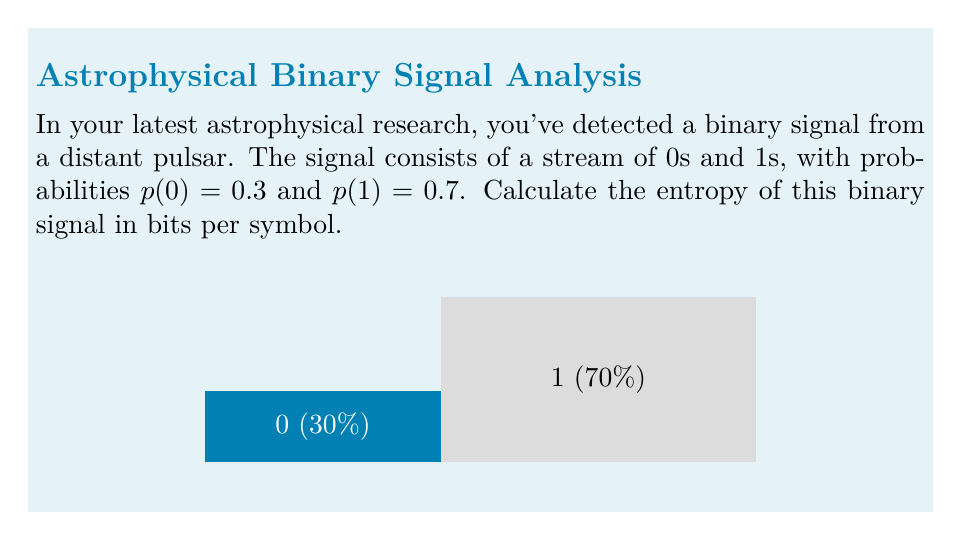Could you help me with this problem? To calculate the entropy of a binary signal, we use Shannon's entropy formula:

$$H = -\sum_{i} p(i) \log_2 p(i)$$

Where $p(i)$ is the probability of each symbol in the signal.

For our binary signal:
1) $p(0) = 0.3$ and $p(1) = 0.7$

2) Let's calculate each term:
   For 0: $-0.3 \log_2(0.3)$
   For 1: $-0.7 \log_2(0.7)$

3) Using a calculator or logarithm properties:
   $-0.3 \log_2(0.3) \approx 0.3219$ bits
   $-0.7 \log_2(0.7) \approx 0.3600$ bits

4) Sum these values:
   $H = 0.3219 + 0.3600 = 0.8819$ bits per symbol

Therefore, the entropy of the binary signal is approximately 0.8819 bits per symbol.
Answer: $0.8819$ bits/symbol 